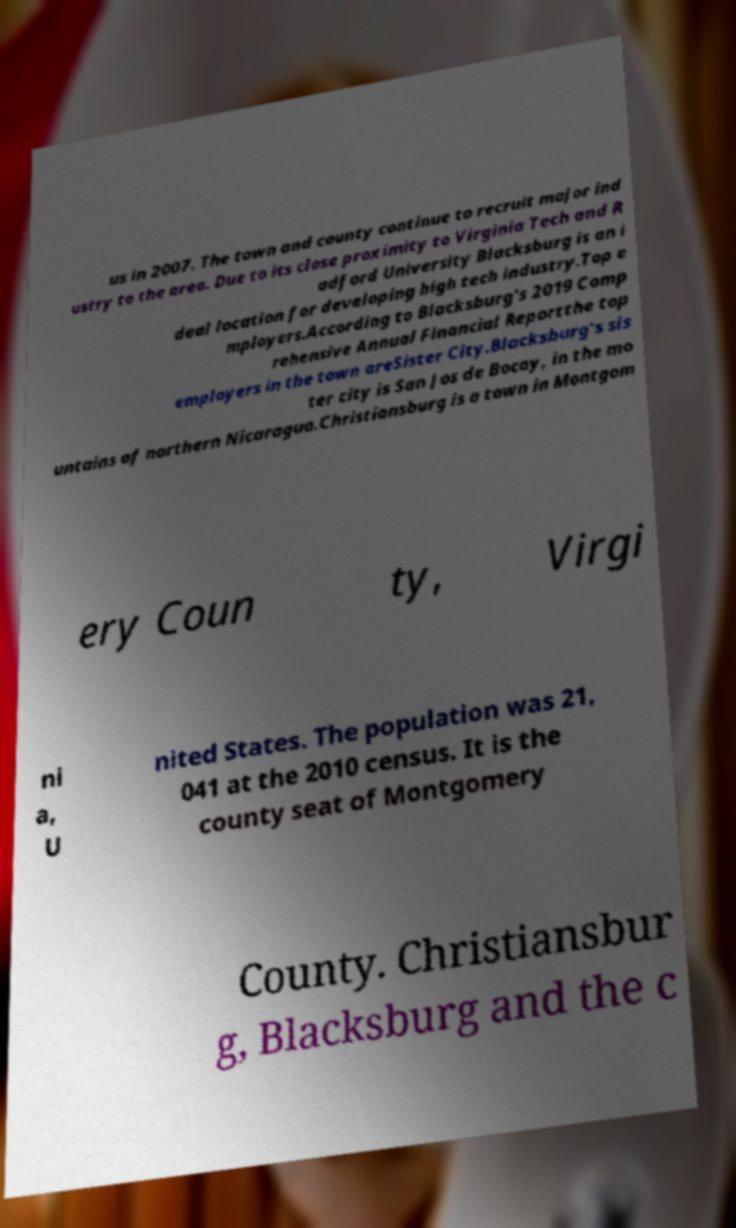Please identify and transcribe the text found in this image. us in 2007. The town and county continue to recruit major ind ustry to the area. Due to its close proximity to Virginia Tech and R adford University Blacksburg is an i deal location for developing high tech industry.Top e mployers.According to Blacksburg's 2019 Comp rehensive Annual Financial Reportthe top employers in the town areSister City.Blacksburg's sis ter city is San Jos de Bocay, in the mo untains of northern Nicaragua.Christiansburg is a town in Montgom ery Coun ty, Virgi ni a, U nited States. The population was 21, 041 at the 2010 census. It is the county seat of Montgomery County. Christiansbur g, Blacksburg and the c 